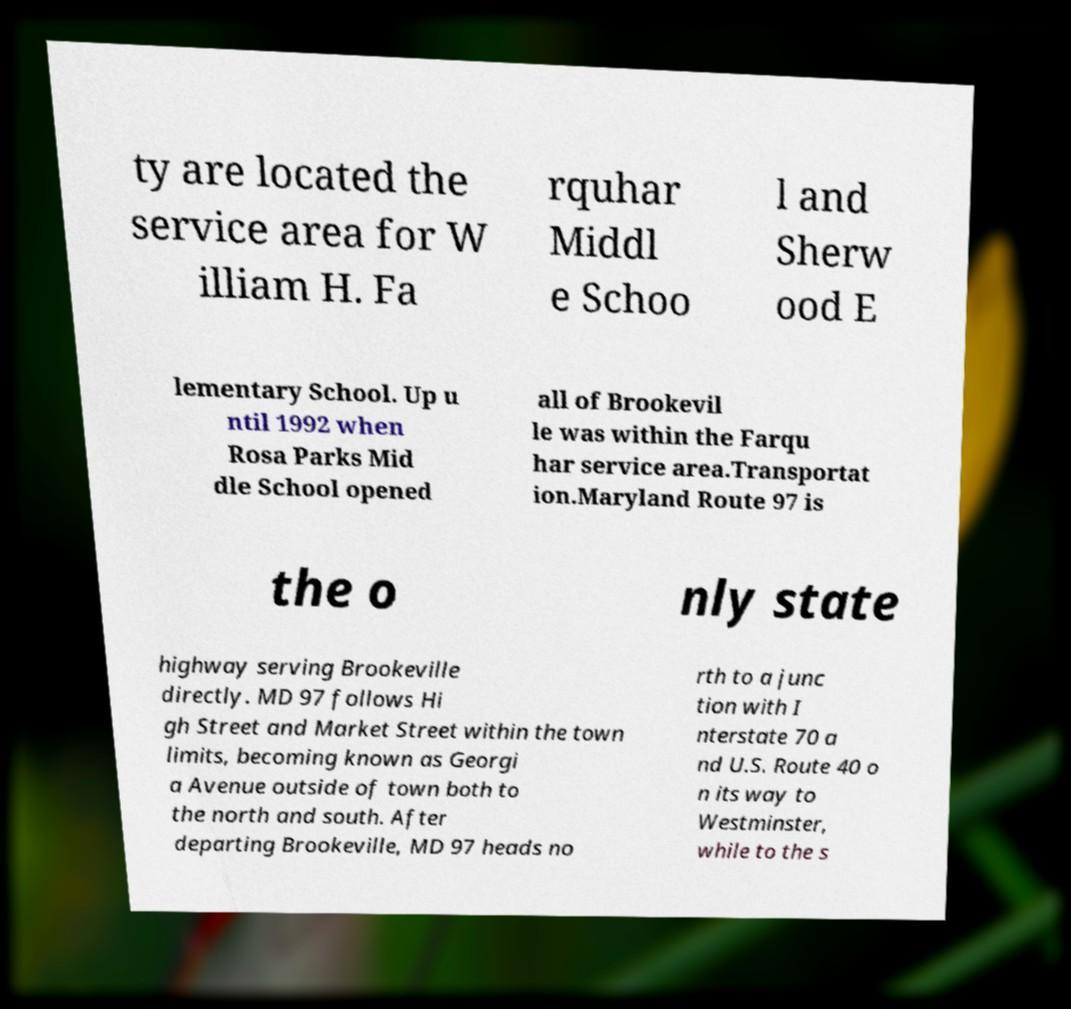What messages or text are displayed in this image? I need them in a readable, typed format. ty are located the service area for W illiam H. Fa rquhar Middl e Schoo l and Sherw ood E lementary School. Up u ntil 1992 when Rosa Parks Mid dle School opened all of Brookevil le was within the Farqu har service area.Transportat ion.Maryland Route 97 is the o nly state highway serving Brookeville directly. MD 97 follows Hi gh Street and Market Street within the town limits, becoming known as Georgi a Avenue outside of town both to the north and south. After departing Brookeville, MD 97 heads no rth to a junc tion with I nterstate 70 a nd U.S. Route 40 o n its way to Westminster, while to the s 